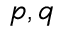Convert formula to latex. <formula><loc_0><loc_0><loc_500><loc_500>p , q</formula> 